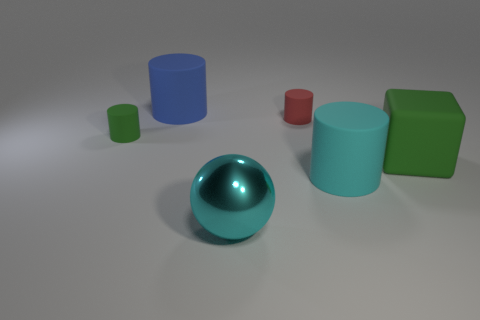Is there a pattern to the arrangement of the objects in this image? There doesn't seem to be a strict pattern, but the objects are spaced out fairly evenly across the surface. They appear to be arranged with attention to balance and contrast in both color and size. 